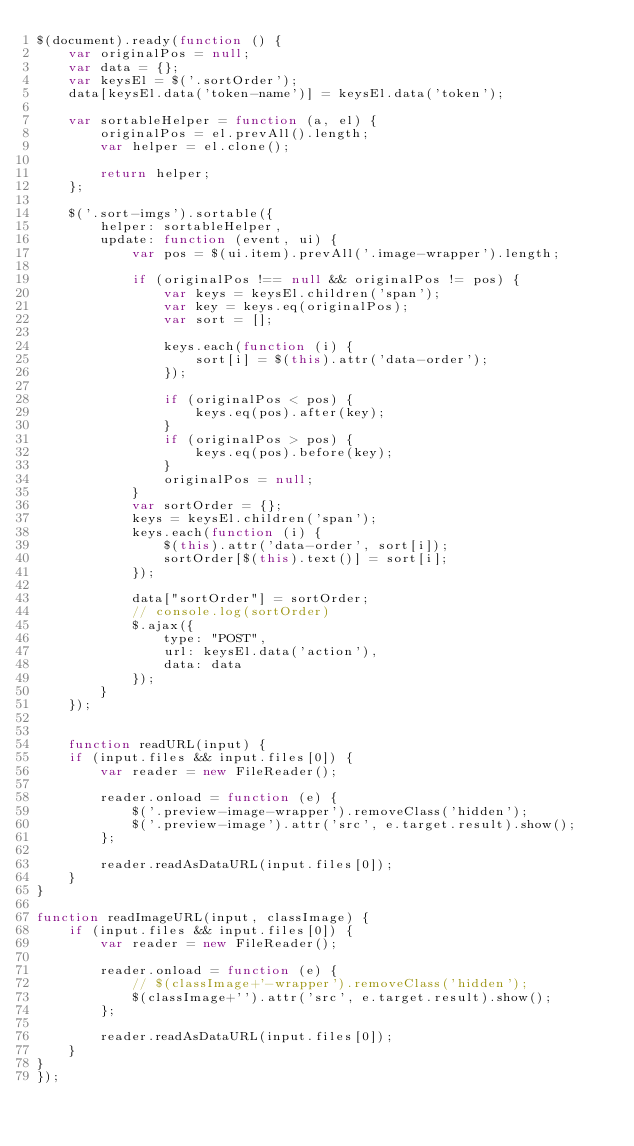<code> <loc_0><loc_0><loc_500><loc_500><_JavaScript_>$(document).ready(function () {
    var originalPos = null;
    var data = {};
    var keysEl = $('.sortOrder');
    data[keysEl.data('token-name')] = keysEl.data('token');

    var sortableHelper = function (a, el) {
        originalPos = el.prevAll().length;
        var helper = el.clone();

        return helper;
    };

    $('.sort-imgs').sortable({
        helper: sortableHelper,
        update: function (event, ui) {
            var pos = $(ui.item).prevAll('.image-wrapper').length;

            if (originalPos !== null && originalPos != pos) {
                var keys = keysEl.children('span');
                var key = keys.eq(originalPos);
                var sort = [];

                keys.each(function (i) {
                    sort[i] = $(this).attr('data-order');
                });

                if (originalPos < pos) {
                    keys.eq(pos).after(key);
                }
                if (originalPos > pos) {
                    keys.eq(pos).before(key);
                }
                originalPos = null;
            }
            var sortOrder = {};
            keys = keysEl.children('span');
            keys.each(function (i) {
                $(this).attr('data-order', sort[i]);
                sortOrder[$(this).text()] = sort[i];
            });

            data["sortOrder"] = sortOrder;
            // console.log(sortOrder)
            $.ajax({
                type: "POST",
                url: keysEl.data('action'),
                data: data
            });
        }
    });


    function readURL(input) {
    if (input.files && input.files[0]) {
        var reader = new FileReader();

        reader.onload = function (e) {
            $('.preview-image-wrapper').removeClass('hidden');
            $('.preview-image').attr('src', e.target.result).show();
        };

        reader.readAsDataURL(input.files[0]);
    }
}

function readImageURL(input, classImage) {
    if (input.files && input.files[0]) {
        var reader = new FileReader();

        reader.onload = function (e) {
            // $(classImage+'-wrapper').removeClass('hidden');
            $(classImage+'').attr('src', e.target.result).show();
        };

        reader.readAsDataURL(input.files[0]);
    }
}
});</code> 